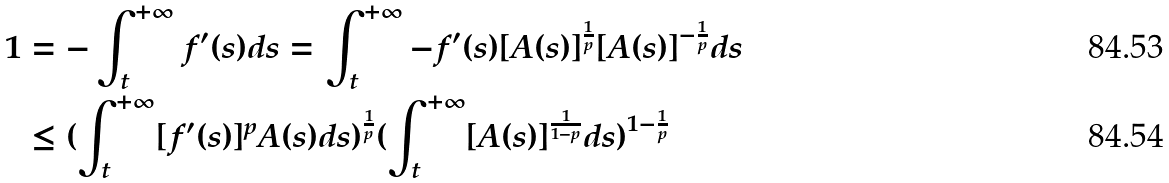<formula> <loc_0><loc_0><loc_500><loc_500>1 & = - \int _ { t } ^ { + \infty } f ^ { \prime } ( s ) d s = \int _ { t } ^ { + \infty } - f ^ { \prime } ( s ) [ A ( s ) ] ^ { \frac { 1 } { p } } [ A ( s ) ] ^ { - \frac { 1 } { p } } d s \\ & \leq ( \int _ { t } ^ { + \infty } [ f ^ { \prime } ( s ) ] ^ { p } A ( s ) d s ) ^ { \frac { 1 } { p } } ( \int _ { t } ^ { + \infty } [ A ( s ) ] ^ { \frac { 1 } { 1 - p } } d s ) ^ { 1 - \frac { 1 } { p } }</formula> 